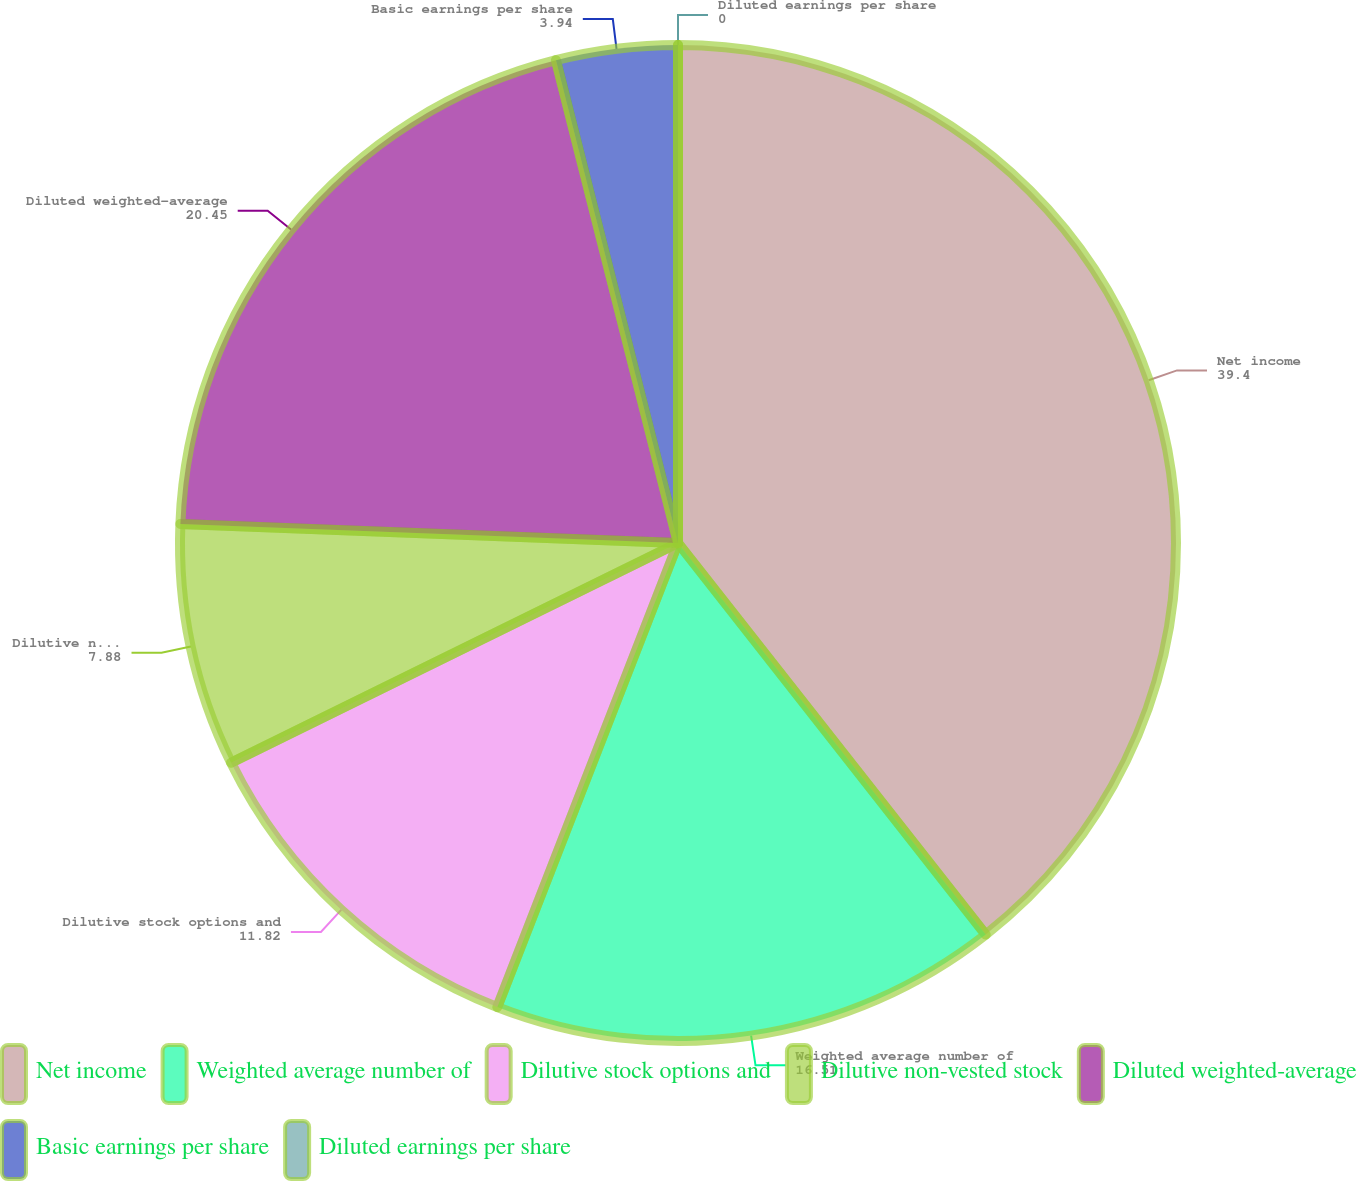Convert chart. <chart><loc_0><loc_0><loc_500><loc_500><pie_chart><fcel>Net income<fcel>Weighted average number of<fcel>Dilutive stock options and<fcel>Dilutive non-vested stock<fcel>Diluted weighted-average<fcel>Basic earnings per share<fcel>Diluted earnings per share<nl><fcel>39.4%<fcel>16.51%<fcel>11.82%<fcel>7.88%<fcel>20.45%<fcel>3.94%<fcel>0.0%<nl></chart> 